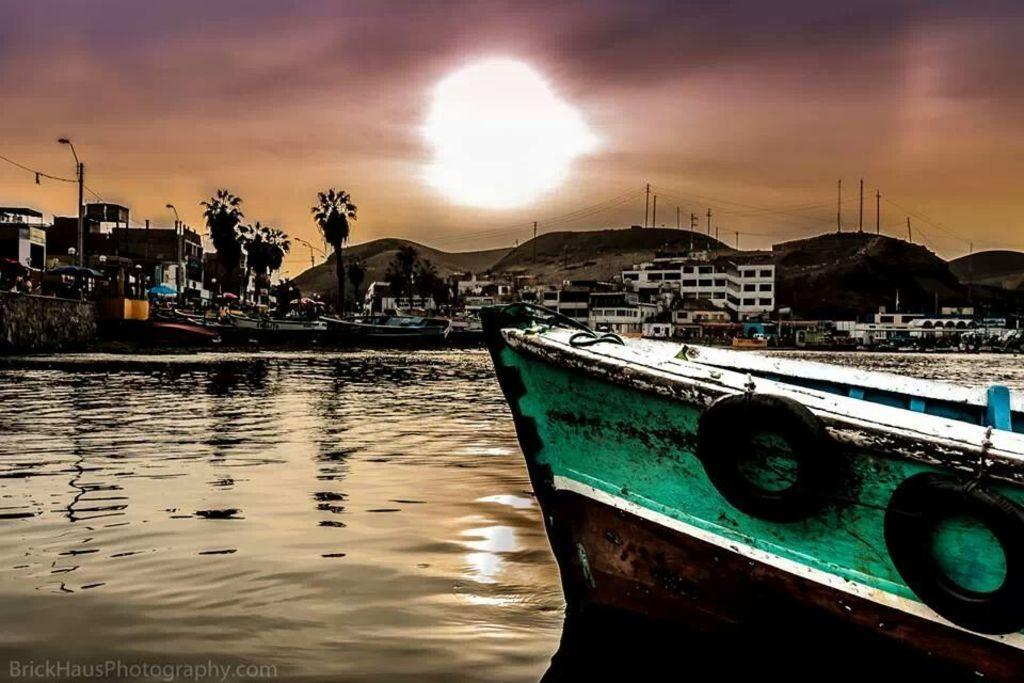What is on the water in the image? There are boats on the water in the image. What else can be seen in the image besides the boats? Buildings, trees, and poles are visible in the image. Where is the text located in the image? The text is at the bottom left corner of the image. Can you tell me how many toads are sitting on the buildings in the image? There are no toads present in the image; it features boats on the water, buildings, trees, and poles. What is the weather like in the image? The provided facts do not mention the weather, so it cannot be determined from the image. 